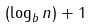<formula> <loc_0><loc_0><loc_500><loc_500>( \log _ { b } n ) + 1</formula> 